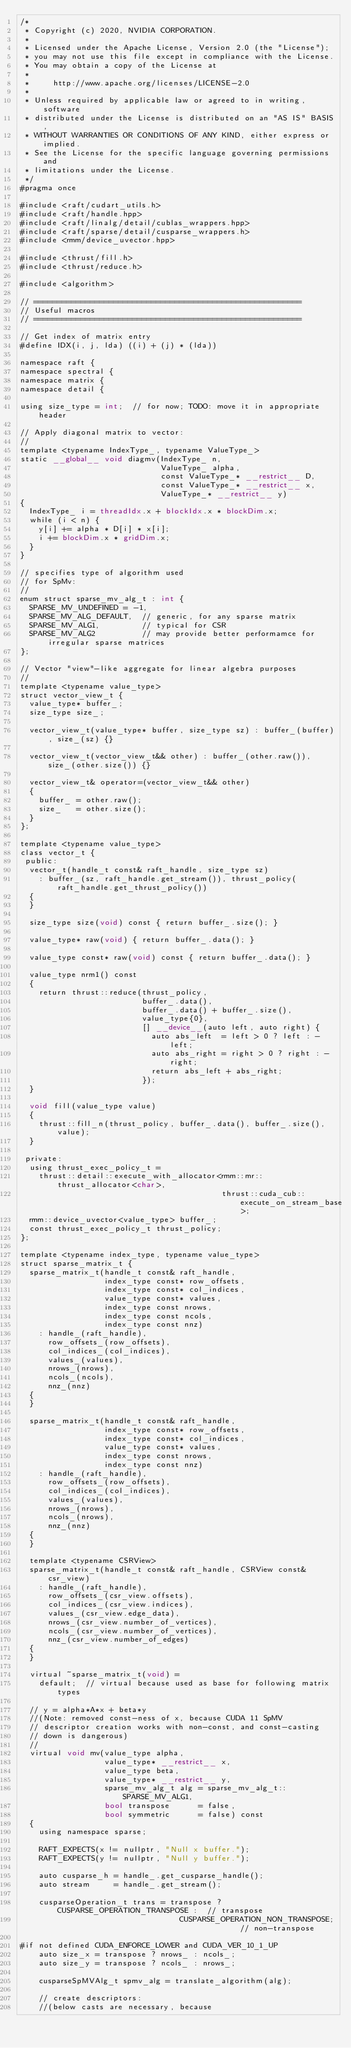Convert code to text. <code><loc_0><loc_0><loc_500><loc_500><_Cuda_>/*
 * Copyright (c) 2020, NVIDIA CORPORATION.
 *
 * Licensed under the Apache License, Version 2.0 (the "License");
 * you may not use this file except in compliance with the License.
 * You may obtain a copy of the License at
 *
 *     http://www.apache.org/licenses/LICENSE-2.0
 *
 * Unless required by applicable law or agreed to in writing, software
 * distributed under the License is distributed on an "AS IS" BASIS,
 * WITHOUT WARRANTIES OR CONDITIONS OF ANY KIND, either express or implied.
 * See the License for the specific language governing permissions and
 * limitations under the License.
 */
#pragma once

#include <raft/cudart_utils.h>
#include <raft/handle.hpp>
#include <raft/linalg/detail/cublas_wrappers.hpp>
#include <raft/sparse/detail/cusparse_wrappers.h>
#include <rmm/device_uvector.hpp>

#include <thrust/fill.h>
#include <thrust/reduce.h>

#include <algorithm>

// =========================================================
// Useful macros
// =========================================================

// Get index of matrix entry
#define IDX(i, j, lda) ((i) + (j) * (lda))

namespace raft {
namespace spectral {
namespace matrix {
namespace detail {

using size_type = int;  // for now; TODO: move it in appropriate header

// Apply diagonal matrix to vector:
//
template <typename IndexType_, typename ValueType_>
static __global__ void diagmv(IndexType_ n,
                              ValueType_ alpha,
                              const ValueType_* __restrict__ D,
                              const ValueType_* __restrict__ x,
                              ValueType_* __restrict__ y)
{
  IndexType_ i = threadIdx.x + blockIdx.x * blockDim.x;
  while (i < n) {
    y[i] += alpha * D[i] * x[i];
    i += blockDim.x * gridDim.x;
  }
}

// specifies type of algorithm used
// for SpMv:
//
enum struct sparse_mv_alg_t : int {
  SPARSE_MV_UNDEFINED = -1,
  SPARSE_MV_ALG_DEFAULT,  // generic, for any sparse matrix
  SPARSE_MV_ALG1,         // typical for CSR
  SPARSE_MV_ALG2          // may provide better performamce for irregular sparse matrices
};

// Vector "view"-like aggregate for linear algebra purposes
//
template <typename value_type>
struct vector_view_t {
  value_type* buffer_;
  size_type size_;

  vector_view_t(value_type* buffer, size_type sz) : buffer_(buffer), size_(sz) {}

  vector_view_t(vector_view_t&& other) : buffer_(other.raw()), size_(other.size()) {}

  vector_view_t& operator=(vector_view_t&& other)
  {
    buffer_ = other.raw();
    size_   = other.size();
  }
};

template <typename value_type>
class vector_t {
 public:
  vector_t(handle_t const& raft_handle, size_type sz)
    : buffer_(sz, raft_handle.get_stream()), thrust_policy(raft_handle.get_thrust_policy())
  {
  }

  size_type size(void) const { return buffer_.size(); }

  value_type* raw(void) { return buffer_.data(); }

  value_type const* raw(void) const { return buffer_.data(); }

  value_type nrm1() const
  {
    return thrust::reduce(thrust_policy,
                          buffer_.data(),
                          buffer_.data() + buffer_.size(),
                          value_type{0},
                          [] __device__(auto left, auto right) {
                            auto abs_left  = left > 0 ? left : -left;
                            auto abs_right = right > 0 ? right : -right;
                            return abs_left + abs_right;
                          });
  }

  void fill(value_type value)
  {
    thrust::fill_n(thrust_policy, buffer_.data(), buffer_.size(), value);
  }

 private:
  using thrust_exec_policy_t =
    thrust::detail::execute_with_allocator<rmm::mr::thrust_allocator<char>,
                                           thrust::cuda_cub::execute_on_stream_base>;
  rmm::device_uvector<value_type> buffer_;
  const thrust_exec_policy_t thrust_policy;
};

template <typename index_type, typename value_type>
struct sparse_matrix_t {
  sparse_matrix_t(handle_t const& raft_handle,
                  index_type const* row_offsets,
                  index_type const* col_indices,
                  value_type const* values,
                  index_type const nrows,
                  index_type const ncols,
                  index_type const nnz)
    : handle_(raft_handle),
      row_offsets_(row_offsets),
      col_indices_(col_indices),
      values_(values),
      nrows_(nrows),
      ncols_(ncols),
      nnz_(nnz)
  {
  }

  sparse_matrix_t(handle_t const& raft_handle,
                  index_type const* row_offsets,
                  index_type const* col_indices,
                  value_type const* values,
                  index_type const nrows,
                  index_type const nnz)
    : handle_(raft_handle),
      row_offsets_(row_offsets),
      col_indices_(col_indices),
      values_(values),
      nrows_(nrows),
      ncols_(nrows),
      nnz_(nnz)
  {
  }

  template <typename CSRView>
  sparse_matrix_t(handle_t const& raft_handle, CSRView const& csr_view)
    : handle_(raft_handle),
      row_offsets_(csr_view.offsets),
      col_indices_(csr_view.indices),
      values_(csr_view.edge_data),
      nrows_(csr_view.number_of_vertices),
      ncols_(csr_view.number_of_vertices),
      nnz_(csr_view.number_of_edges)
  {
  }

  virtual ~sparse_matrix_t(void) =
    default;  // virtual because used as base for following matrix types

  // y = alpha*A*x + beta*y
  //(Note: removed const-ness of x, because CUDA 11 SpMV
  // descriptor creation works with non-const, and const-casting
  // down is dangerous)
  //
  virtual void mv(value_type alpha,
                  value_type* __restrict__ x,
                  value_type beta,
                  value_type* __restrict__ y,
                  sparse_mv_alg_t alg = sparse_mv_alg_t::SPARSE_MV_ALG1,
                  bool transpose      = false,
                  bool symmetric      = false) const
  {
    using namespace sparse;

    RAFT_EXPECTS(x != nullptr, "Null x buffer.");
    RAFT_EXPECTS(y != nullptr, "Null y buffer.");

    auto cusparse_h = handle_.get_cusparse_handle();
    auto stream     = handle_.get_stream();

    cusparseOperation_t trans = transpose ? CUSPARSE_OPERATION_TRANSPOSE :  // transpose
                                  CUSPARSE_OPERATION_NON_TRANSPOSE;         // non-transpose

#if not defined CUDA_ENFORCE_LOWER and CUDA_VER_10_1_UP
    auto size_x = transpose ? nrows_ : ncols_;
    auto size_y = transpose ? ncols_ : nrows_;

    cusparseSpMVAlg_t spmv_alg = translate_algorithm(alg);

    // create descriptors:
    //(below casts are necessary, because</code> 